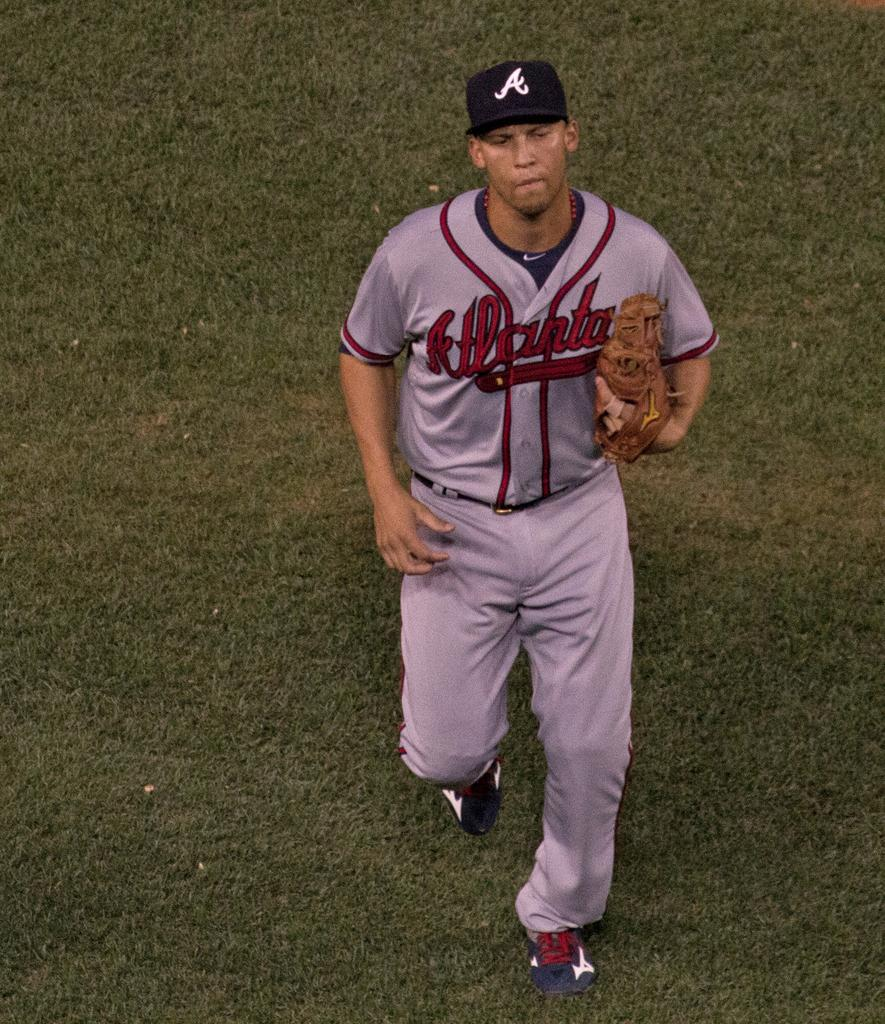Provide a one-sentence caption for the provided image. An Atlanta baseball player is running on the baseball field. 